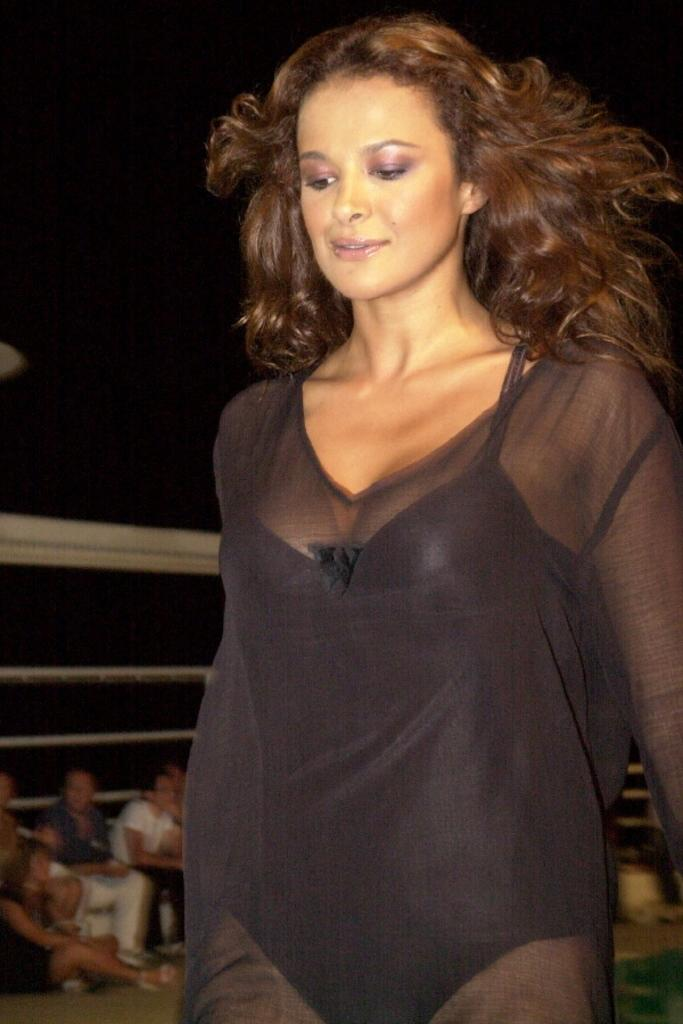How many people are in the image? There are people in the image, but the exact number is not specified. Can you describe the lady's attire in the image? There is a lady wearing a black dress in the image. What type of structure can be seen in the image? There is a fence in the image. What is visible beneath the people's feet in the image? The ground is visible in the image. How would you describe the sky's appearance in the image? The sky is dark in the image. What type of bottle is the lady holding in the image? There is no bottle present in the image. What color is the yarn being used by the committee in the image? There is no committee or yarn present in the image. 